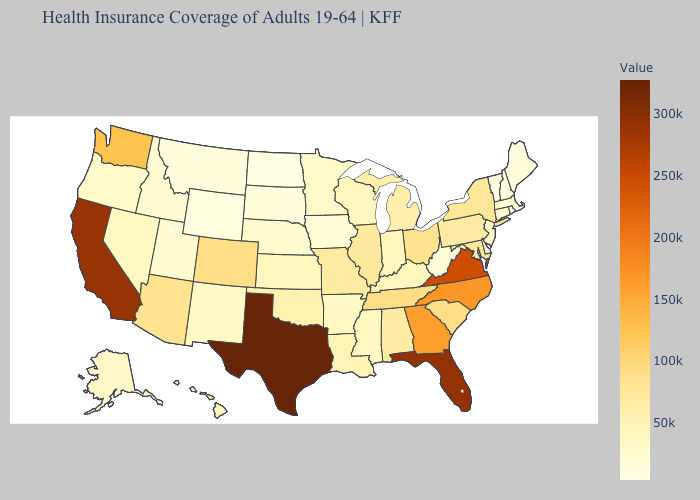Does South Dakota have the highest value in the USA?
Concise answer only. No. Which states have the lowest value in the USA?
Short answer required. Vermont. Which states have the lowest value in the MidWest?
Write a very short answer. North Dakota. Is the legend a continuous bar?
Be succinct. Yes. Which states have the lowest value in the USA?
Write a very short answer. Vermont. Which states have the highest value in the USA?
Be succinct. Texas. Does Arizona have the lowest value in the West?
Write a very short answer. No. Which states hav the highest value in the South?
Keep it brief. Texas. Does Alabama have the lowest value in the South?
Concise answer only. No. Does South Carolina have the lowest value in the USA?
Keep it brief. No. 